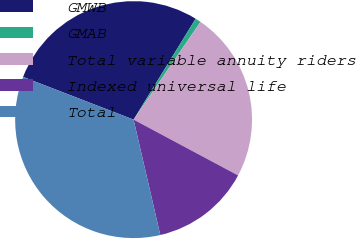Convert chart. <chart><loc_0><loc_0><loc_500><loc_500><pie_chart><fcel>GMWB<fcel>GMAB<fcel>Total variable annuity riders<fcel>Indexed universal life<fcel>Total<nl><fcel>27.91%<fcel>0.78%<fcel>23.26%<fcel>13.57%<fcel>34.5%<nl></chart> 